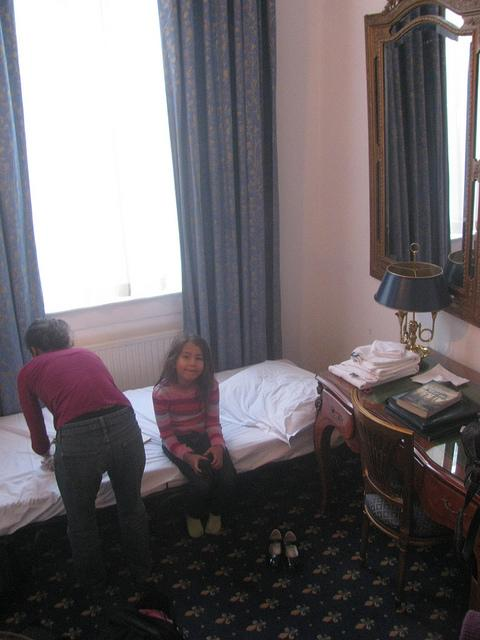Why does she haver her shoes off? bed laying 